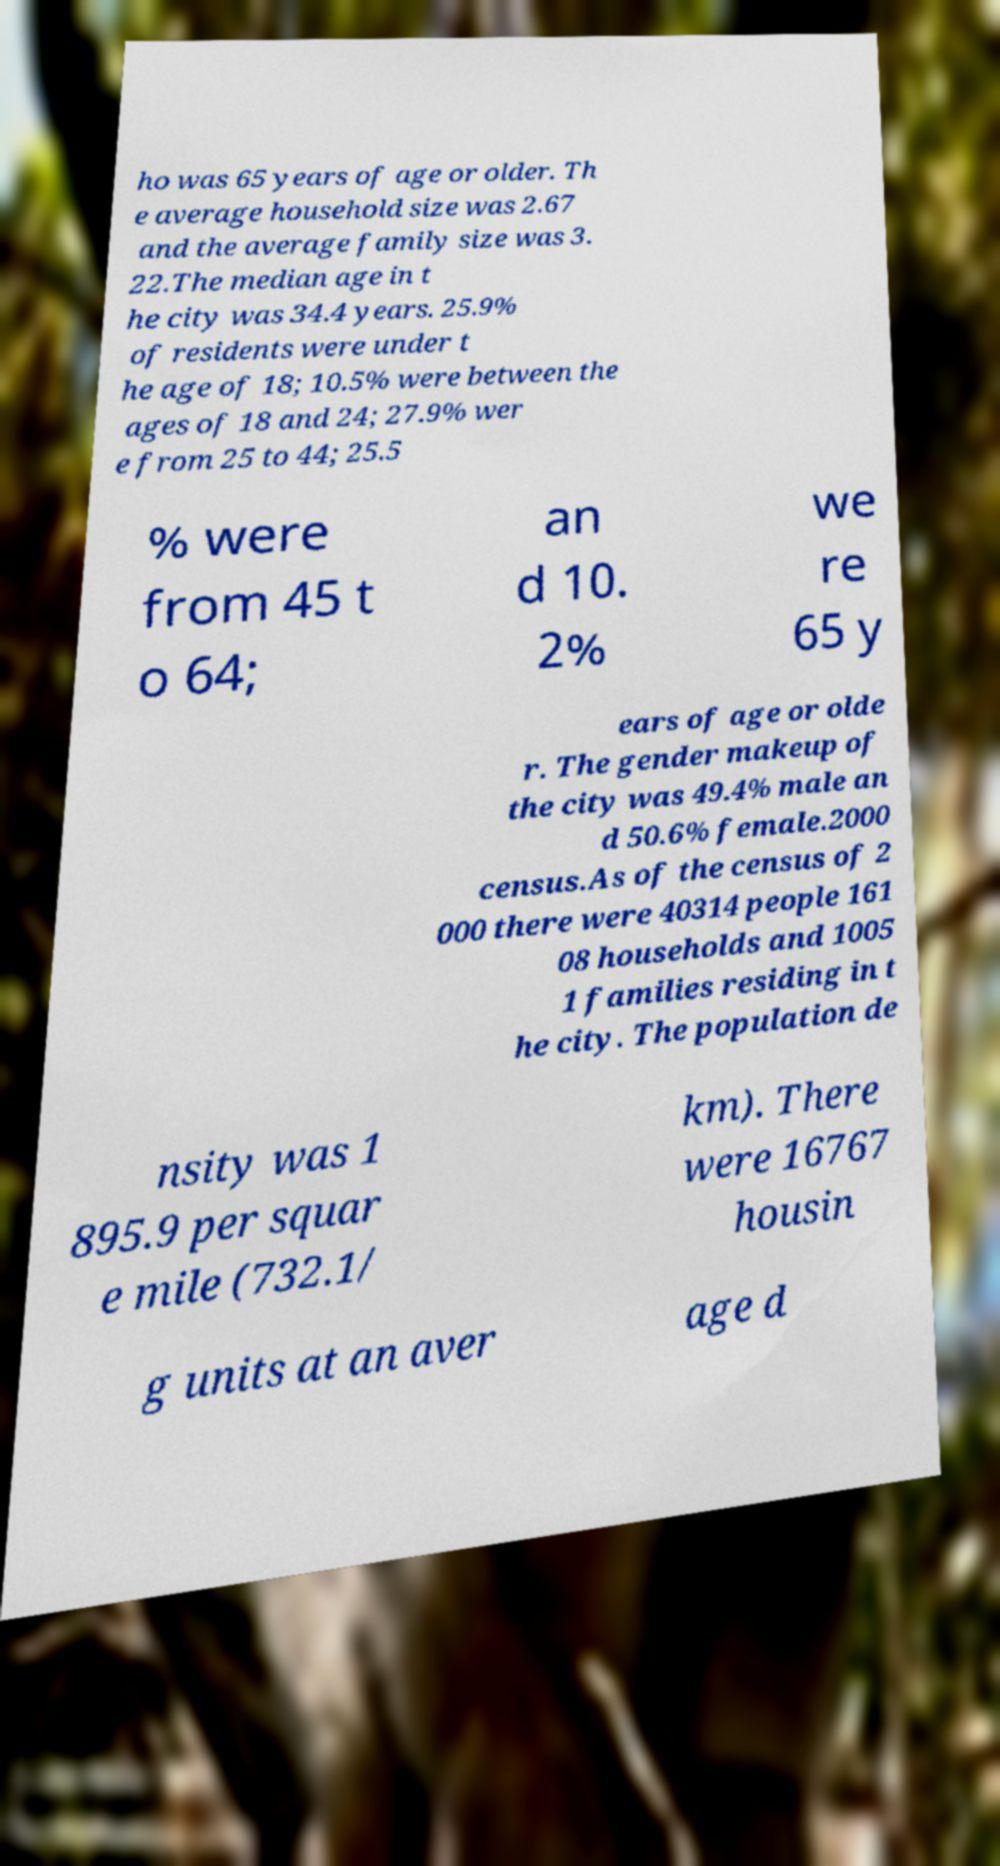Please identify and transcribe the text found in this image. ho was 65 years of age or older. Th e average household size was 2.67 and the average family size was 3. 22.The median age in t he city was 34.4 years. 25.9% of residents were under t he age of 18; 10.5% were between the ages of 18 and 24; 27.9% wer e from 25 to 44; 25.5 % were from 45 t o 64; an d 10. 2% we re 65 y ears of age or olde r. The gender makeup of the city was 49.4% male an d 50.6% female.2000 census.As of the census of 2 000 there were 40314 people 161 08 households and 1005 1 families residing in t he city. The population de nsity was 1 895.9 per squar e mile (732.1/ km). There were 16767 housin g units at an aver age d 